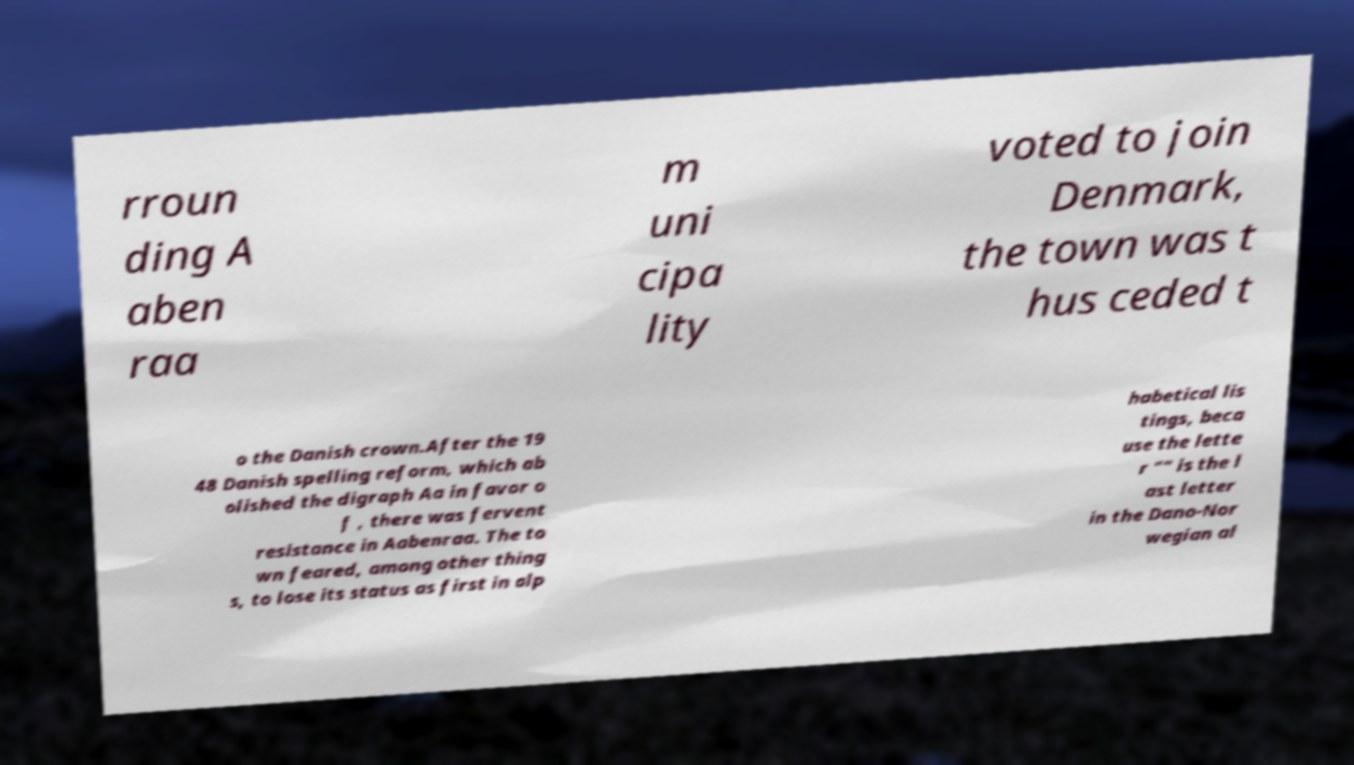Please read and relay the text visible in this image. What does it say? rroun ding A aben raa m uni cipa lity voted to join Denmark, the town was t hus ceded t o the Danish crown.After the 19 48 Danish spelling reform, which ab olished the digraph Aa in favor o f , there was fervent resistance in Aabenraa. The to wn feared, among other thing s, to lose its status as first in alp habetical lis tings, beca use the lette r "" is the l ast letter in the Dano-Nor wegian al 